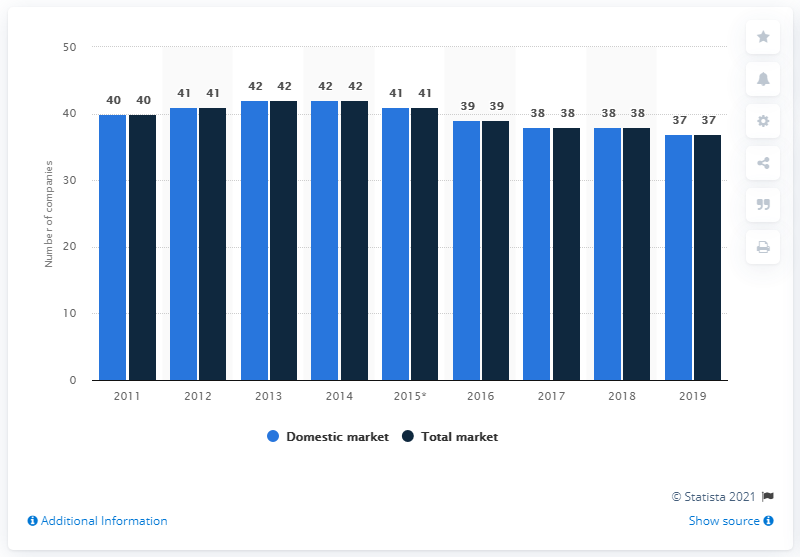Give some essential details in this illustration. At the end of 2019, 37 companies were present. 